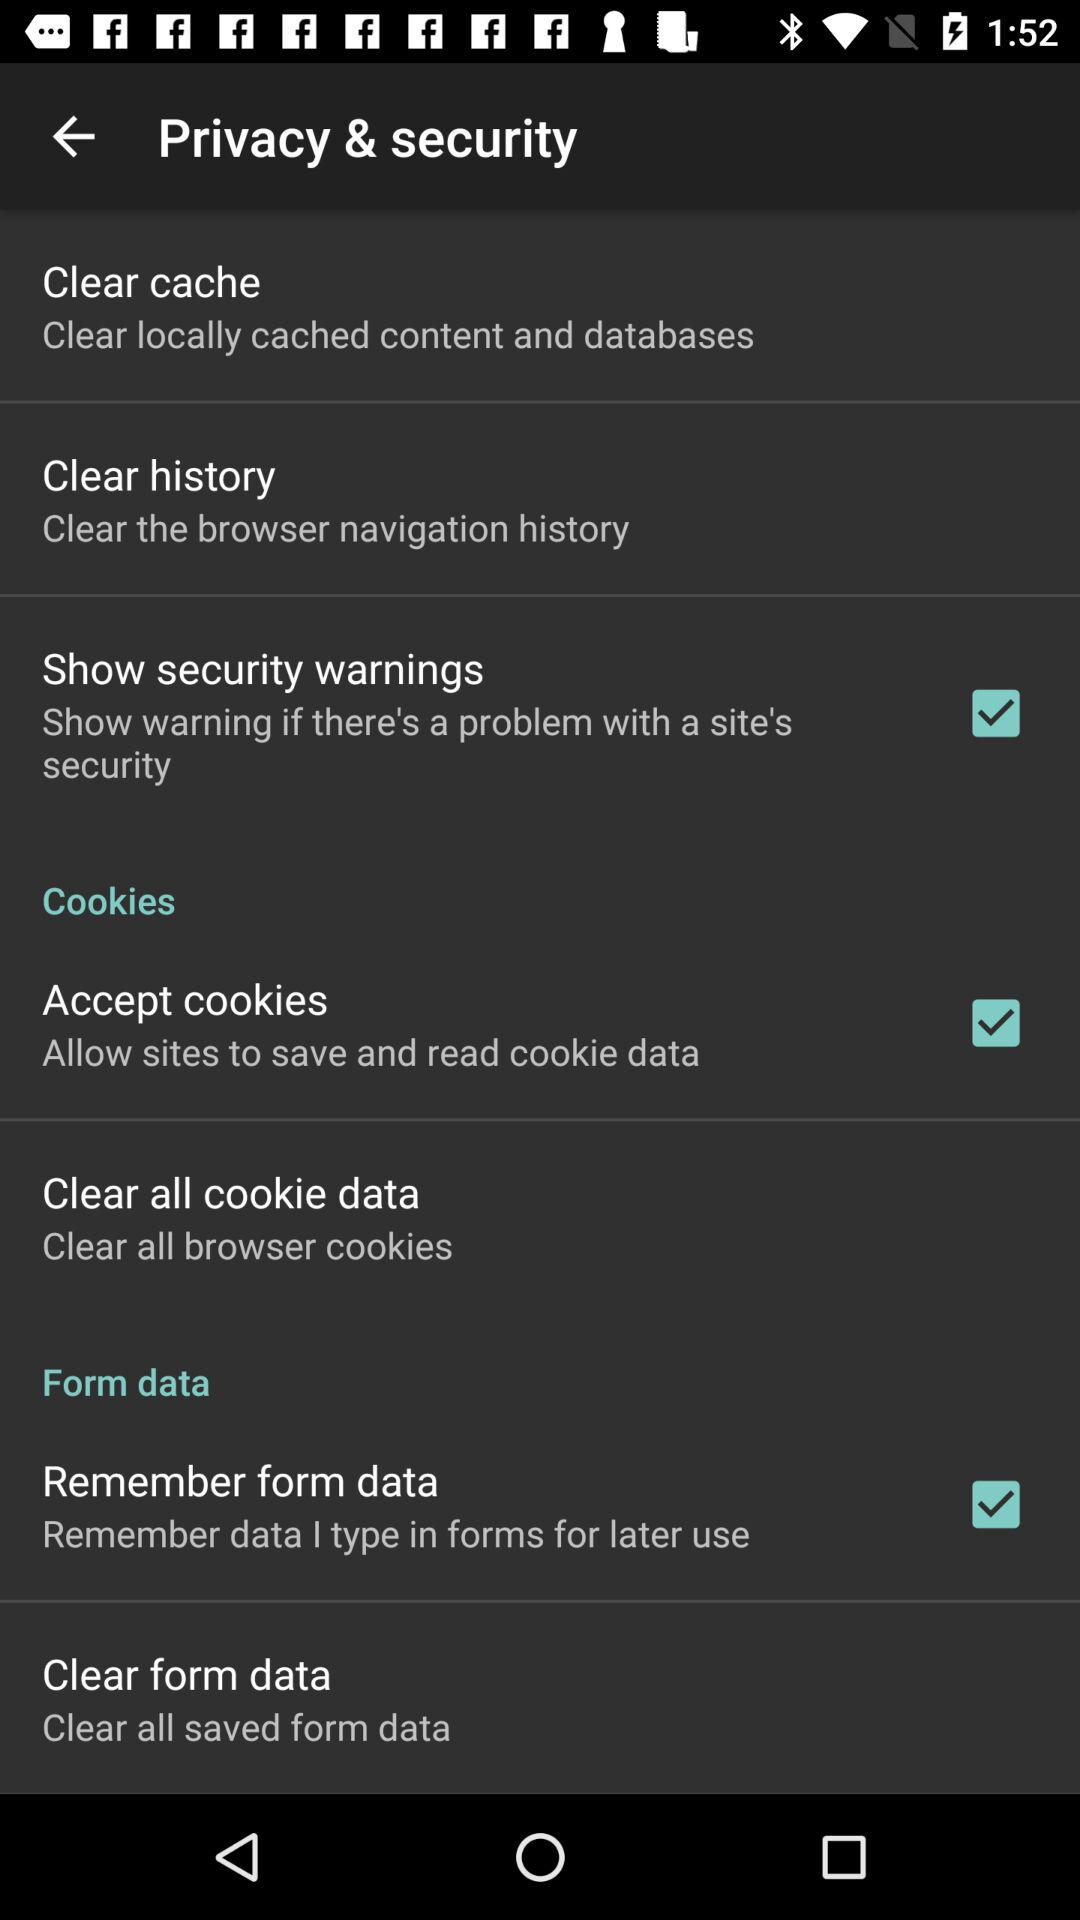What is the status of "Show security warnings"? The status is "on". 